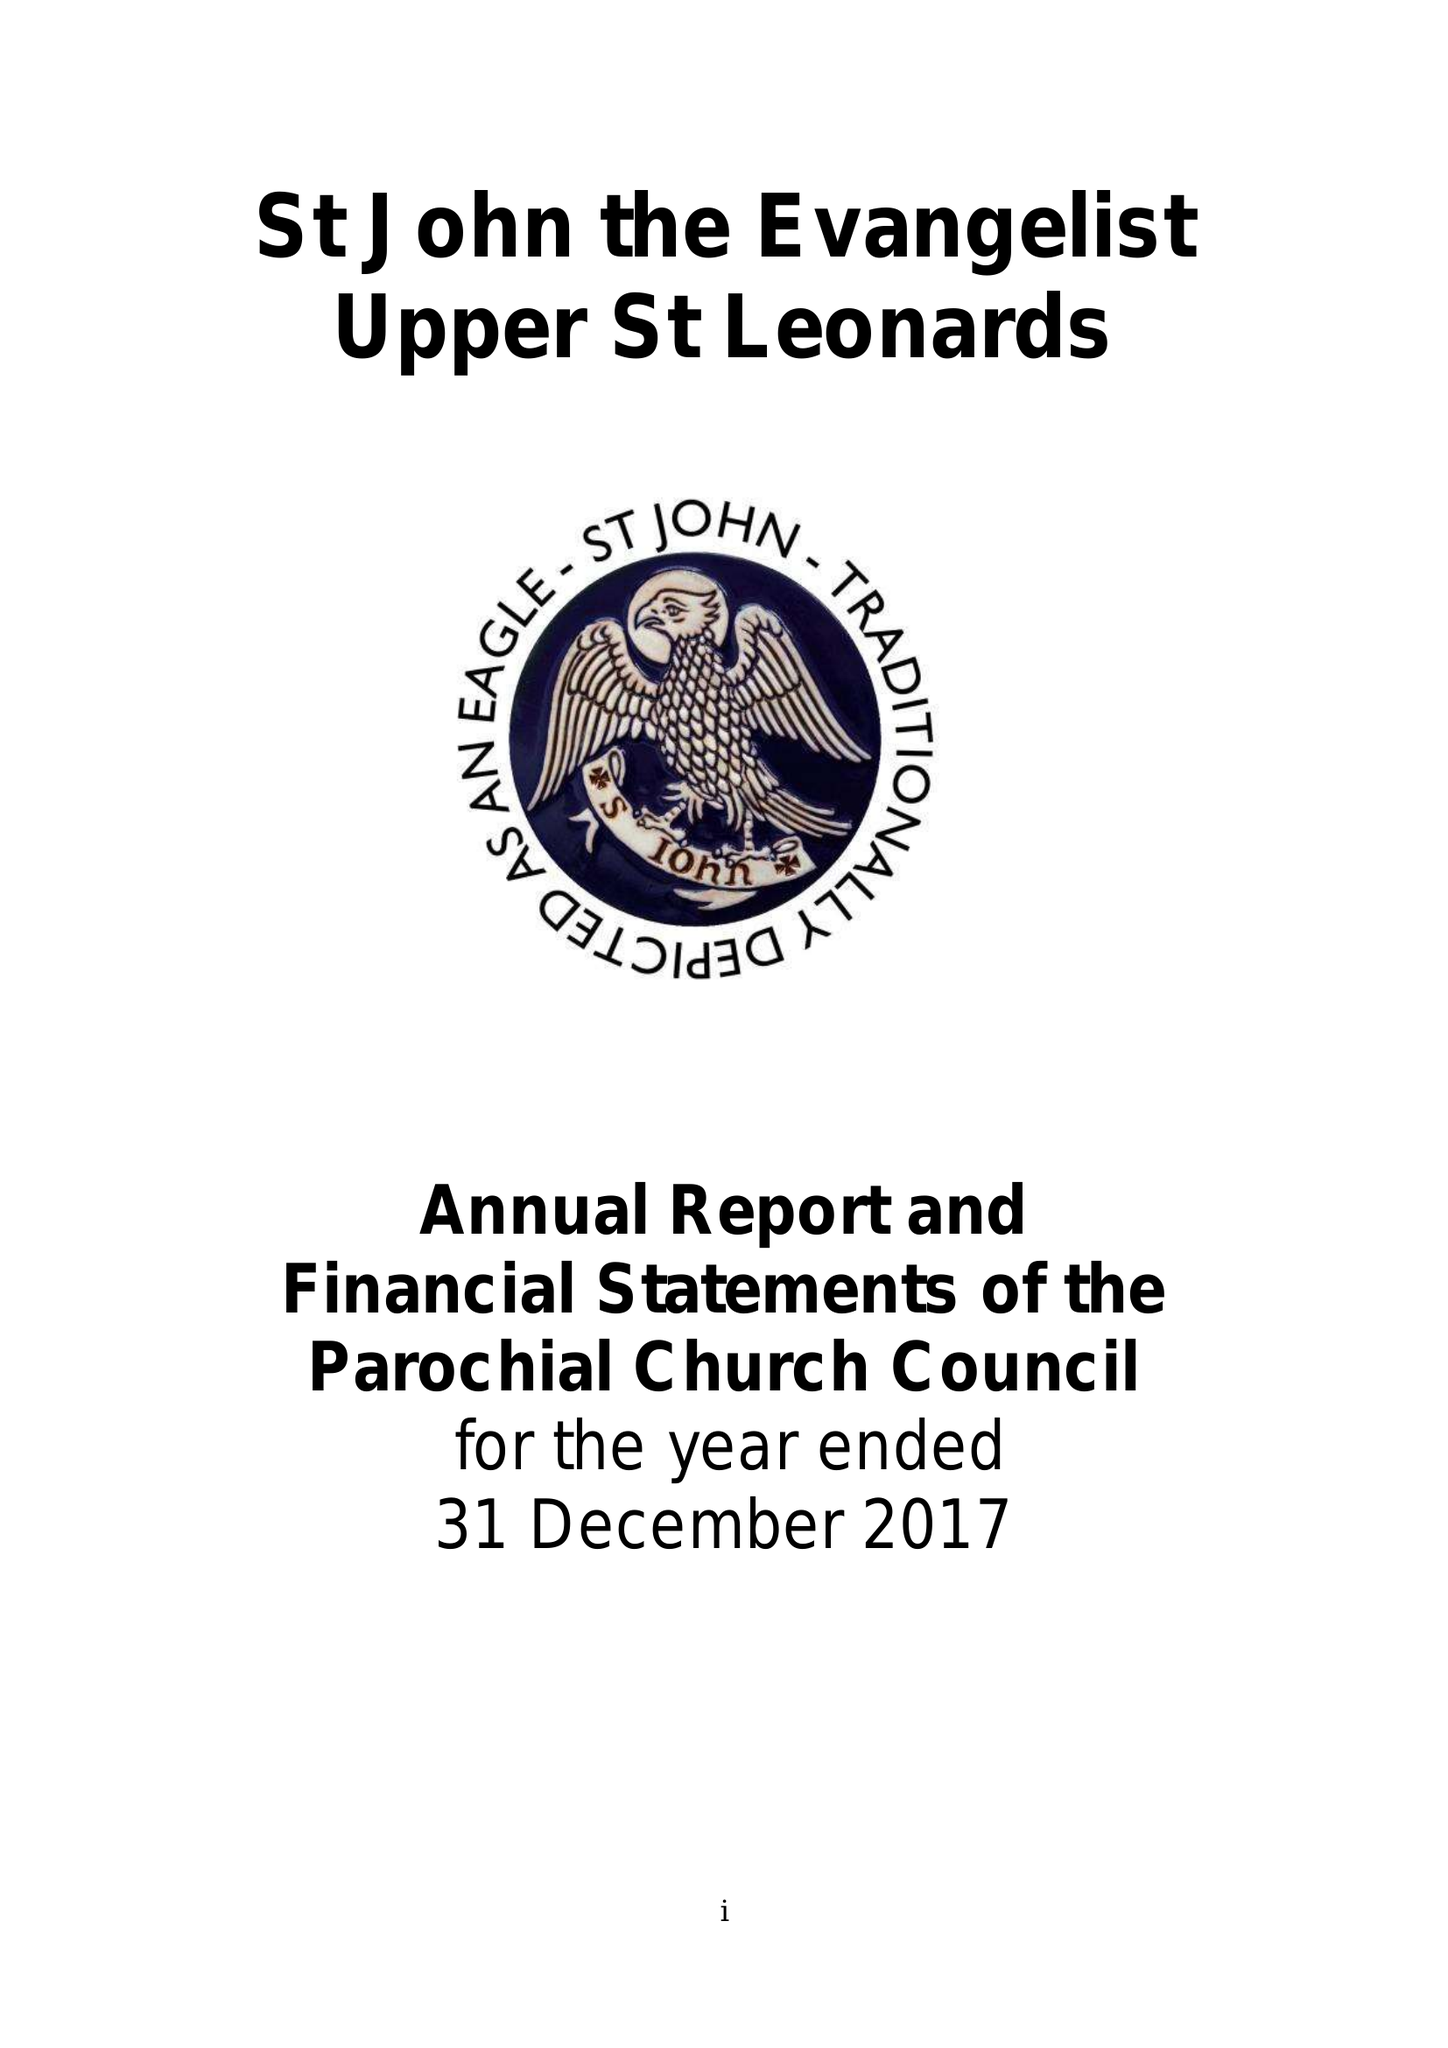What is the value for the report_date?
Answer the question using a single word or phrase. 2015-12-31 